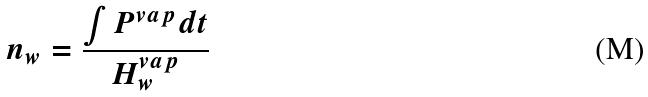<formula> <loc_0><loc_0><loc_500><loc_500>n _ { w } = \frac { \int P ^ { v a p } d t } { H _ { w } ^ { v a p } }</formula> 